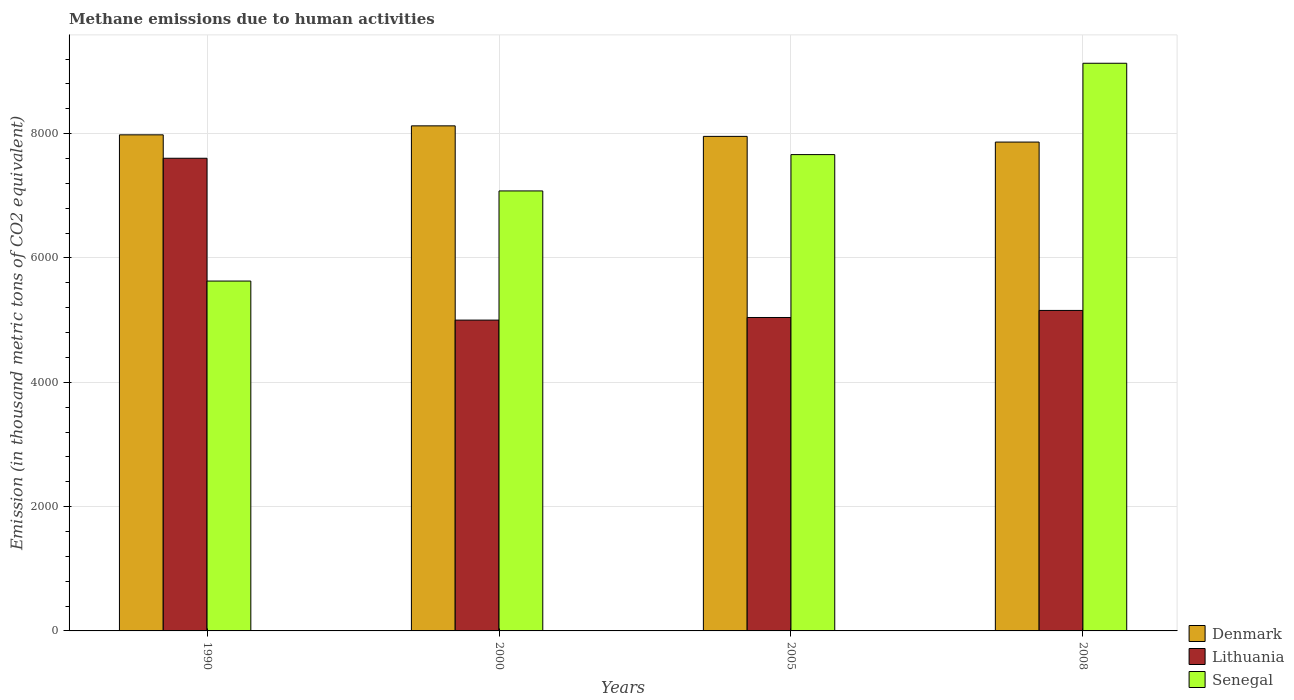How many different coloured bars are there?
Your answer should be compact. 3. Are the number of bars on each tick of the X-axis equal?
Your response must be concise. Yes. What is the amount of methane emitted in Senegal in 2000?
Offer a terse response. 7078.1. Across all years, what is the maximum amount of methane emitted in Lithuania?
Your response must be concise. 7603.6. Across all years, what is the minimum amount of methane emitted in Denmark?
Provide a succinct answer. 7864.1. What is the total amount of methane emitted in Lithuania in the graph?
Give a very brief answer. 2.28e+04. What is the difference between the amount of methane emitted in Lithuania in 1990 and that in 2000?
Your answer should be very brief. 2603.4. What is the difference between the amount of methane emitted in Lithuania in 2005 and the amount of methane emitted in Denmark in 1990?
Your answer should be compact. -2938.3. What is the average amount of methane emitted in Senegal per year?
Give a very brief answer. 7375.15. In the year 2005, what is the difference between the amount of methane emitted in Lithuania and amount of methane emitted in Senegal?
Keep it short and to the point. -2620.2. What is the ratio of the amount of methane emitted in Denmark in 2005 to that in 2008?
Give a very brief answer. 1.01. What is the difference between the highest and the second highest amount of methane emitted in Lithuania?
Provide a succinct answer. 2447.8. What is the difference between the highest and the lowest amount of methane emitted in Lithuania?
Provide a succinct answer. 2603.4. Is the sum of the amount of methane emitted in Lithuania in 2000 and 2005 greater than the maximum amount of methane emitted in Denmark across all years?
Provide a succinct answer. Yes. What does the 3rd bar from the left in 2008 represents?
Your answer should be compact. Senegal. What does the 2nd bar from the right in 2008 represents?
Your answer should be very brief. Lithuania. How many bars are there?
Provide a short and direct response. 12. Are all the bars in the graph horizontal?
Keep it short and to the point. No. What is the difference between two consecutive major ticks on the Y-axis?
Provide a succinct answer. 2000. Are the values on the major ticks of Y-axis written in scientific E-notation?
Keep it short and to the point. No. Does the graph contain any zero values?
Keep it short and to the point. No. Does the graph contain grids?
Keep it short and to the point. Yes. How many legend labels are there?
Offer a terse response. 3. How are the legend labels stacked?
Your answer should be very brief. Vertical. What is the title of the graph?
Give a very brief answer. Methane emissions due to human activities. Does "OECD members" appear as one of the legend labels in the graph?
Your answer should be compact. No. What is the label or title of the Y-axis?
Your response must be concise. Emission (in thousand metric tons of CO2 equivalent). What is the Emission (in thousand metric tons of CO2 equivalent) in Denmark in 1990?
Ensure brevity in your answer.  7980.5. What is the Emission (in thousand metric tons of CO2 equivalent) in Lithuania in 1990?
Provide a short and direct response. 7603.6. What is the Emission (in thousand metric tons of CO2 equivalent) of Senegal in 1990?
Provide a succinct answer. 5628.2. What is the Emission (in thousand metric tons of CO2 equivalent) of Denmark in 2000?
Your answer should be compact. 8124.9. What is the Emission (in thousand metric tons of CO2 equivalent) of Lithuania in 2000?
Your answer should be very brief. 5000.2. What is the Emission (in thousand metric tons of CO2 equivalent) in Senegal in 2000?
Your answer should be very brief. 7078.1. What is the Emission (in thousand metric tons of CO2 equivalent) of Denmark in 2005?
Give a very brief answer. 7955.5. What is the Emission (in thousand metric tons of CO2 equivalent) of Lithuania in 2005?
Your answer should be compact. 5042.2. What is the Emission (in thousand metric tons of CO2 equivalent) in Senegal in 2005?
Keep it short and to the point. 7662.4. What is the Emission (in thousand metric tons of CO2 equivalent) of Denmark in 2008?
Provide a succinct answer. 7864.1. What is the Emission (in thousand metric tons of CO2 equivalent) in Lithuania in 2008?
Provide a short and direct response. 5155.8. What is the Emission (in thousand metric tons of CO2 equivalent) of Senegal in 2008?
Your response must be concise. 9131.9. Across all years, what is the maximum Emission (in thousand metric tons of CO2 equivalent) of Denmark?
Make the answer very short. 8124.9. Across all years, what is the maximum Emission (in thousand metric tons of CO2 equivalent) of Lithuania?
Your answer should be compact. 7603.6. Across all years, what is the maximum Emission (in thousand metric tons of CO2 equivalent) in Senegal?
Provide a succinct answer. 9131.9. Across all years, what is the minimum Emission (in thousand metric tons of CO2 equivalent) of Denmark?
Keep it short and to the point. 7864.1. Across all years, what is the minimum Emission (in thousand metric tons of CO2 equivalent) in Lithuania?
Ensure brevity in your answer.  5000.2. Across all years, what is the minimum Emission (in thousand metric tons of CO2 equivalent) of Senegal?
Offer a terse response. 5628.2. What is the total Emission (in thousand metric tons of CO2 equivalent) of Denmark in the graph?
Offer a very short reply. 3.19e+04. What is the total Emission (in thousand metric tons of CO2 equivalent) of Lithuania in the graph?
Offer a very short reply. 2.28e+04. What is the total Emission (in thousand metric tons of CO2 equivalent) in Senegal in the graph?
Offer a terse response. 2.95e+04. What is the difference between the Emission (in thousand metric tons of CO2 equivalent) of Denmark in 1990 and that in 2000?
Give a very brief answer. -144.4. What is the difference between the Emission (in thousand metric tons of CO2 equivalent) in Lithuania in 1990 and that in 2000?
Your response must be concise. 2603.4. What is the difference between the Emission (in thousand metric tons of CO2 equivalent) of Senegal in 1990 and that in 2000?
Provide a short and direct response. -1449.9. What is the difference between the Emission (in thousand metric tons of CO2 equivalent) in Lithuania in 1990 and that in 2005?
Give a very brief answer. 2561.4. What is the difference between the Emission (in thousand metric tons of CO2 equivalent) in Senegal in 1990 and that in 2005?
Offer a very short reply. -2034.2. What is the difference between the Emission (in thousand metric tons of CO2 equivalent) in Denmark in 1990 and that in 2008?
Offer a terse response. 116.4. What is the difference between the Emission (in thousand metric tons of CO2 equivalent) in Lithuania in 1990 and that in 2008?
Provide a succinct answer. 2447.8. What is the difference between the Emission (in thousand metric tons of CO2 equivalent) of Senegal in 1990 and that in 2008?
Your answer should be very brief. -3503.7. What is the difference between the Emission (in thousand metric tons of CO2 equivalent) in Denmark in 2000 and that in 2005?
Provide a short and direct response. 169.4. What is the difference between the Emission (in thousand metric tons of CO2 equivalent) of Lithuania in 2000 and that in 2005?
Ensure brevity in your answer.  -42. What is the difference between the Emission (in thousand metric tons of CO2 equivalent) of Senegal in 2000 and that in 2005?
Your answer should be compact. -584.3. What is the difference between the Emission (in thousand metric tons of CO2 equivalent) in Denmark in 2000 and that in 2008?
Provide a short and direct response. 260.8. What is the difference between the Emission (in thousand metric tons of CO2 equivalent) in Lithuania in 2000 and that in 2008?
Make the answer very short. -155.6. What is the difference between the Emission (in thousand metric tons of CO2 equivalent) of Senegal in 2000 and that in 2008?
Your answer should be compact. -2053.8. What is the difference between the Emission (in thousand metric tons of CO2 equivalent) of Denmark in 2005 and that in 2008?
Make the answer very short. 91.4. What is the difference between the Emission (in thousand metric tons of CO2 equivalent) in Lithuania in 2005 and that in 2008?
Give a very brief answer. -113.6. What is the difference between the Emission (in thousand metric tons of CO2 equivalent) of Senegal in 2005 and that in 2008?
Give a very brief answer. -1469.5. What is the difference between the Emission (in thousand metric tons of CO2 equivalent) of Denmark in 1990 and the Emission (in thousand metric tons of CO2 equivalent) of Lithuania in 2000?
Your response must be concise. 2980.3. What is the difference between the Emission (in thousand metric tons of CO2 equivalent) in Denmark in 1990 and the Emission (in thousand metric tons of CO2 equivalent) in Senegal in 2000?
Your answer should be very brief. 902.4. What is the difference between the Emission (in thousand metric tons of CO2 equivalent) in Lithuania in 1990 and the Emission (in thousand metric tons of CO2 equivalent) in Senegal in 2000?
Ensure brevity in your answer.  525.5. What is the difference between the Emission (in thousand metric tons of CO2 equivalent) in Denmark in 1990 and the Emission (in thousand metric tons of CO2 equivalent) in Lithuania in 2005?
Give a very brief answer. 2938.3. What is the difference between the Emission (in thousand metric tons of CO2 equivalent) of Denmark in 1990 and the Emission (in thousand metric tons of CO2 equivalent) of Senegal in 2005?
Your answer should be very brief. 318.1. What is the difference between the Emission (in thousand metric tons of CO2 equivalent) of Lithuania in 1990 and the Emission (in thousand metric tons of CO2 equivalent) of Senegal in 2005?
Make the answer very short. -58.8. What is the difference between the Emission (in thousand metric tons of CO2 equivalent) in Denmark in 1990 and the Emission (in thousand metric tons of CO2 equivalent) in Lithuania in 2008?
Ensure brevity in your answer.  2824.7. What is the difference between the Emission (in thousand metric tons of CO2 equivalent) of Denmark in 1990 and the Emission (in thousand metric tons of CO2 equivalent) of Senegal in 2008?
Ensure brevity in your answer.  -1151.4. What is the difference between the Emission (in thousand metric tons of CO2 equivalent) of Lithuania in 1990 and the Emission (in thousand metric tons of CO2 equivalent) of Senegal in 2008?
Ensure brevity in your answer.  -1528.3. What is the difference between the Emission (in thousand metric tons of CO2 equivalent) of Denmark in 2000 and the Emission (in thousand metric tons of CO2 equivalent) of Lithuania in 2005?
Your answer should be compact. 3082.7. What is the difference between the Emission (in thousand metric tons of CO2 equivalent) of Denmark in 2000 and the Emission (in thousand metric tons of CO2 equivalent) of Senegal in 2005?
Your response must be concise. 462.5. What is the difference between the Emission (in thousand metric tons of CO2 equivalent) in Lithuania in 2000 and the Emission (in thousand metric tons of CO2 equivalent) in Senegal in 2005?
Provide a succinct answer. -2662.2. What is the difference between the Emission (in thousand metric tons of CO2 equivalent) of Denmark in 2000 and the Emission (in thousand metric tons of CO2 equivalent) of Lithuania in 2008?
Offer a terse response. 2969.1. What is the difference between the Emission (in thousand metric tons of CO2 equivalent) in Denmark in 2000 and the Emission (in thousand metric tons of CO2 equivalent) in Senegal in 2008?
Your answer should be very brief. -1007. What is the difference between the Emission (in thousand metric tons of CO2 equivalent) in Lithuania in 2000 and the Emission (in thousand metric tons of CO2 equivalent) in Senegal in 2008?
Give a very brief answer. -4131.7. What is the difference between the Emission (in thousand metric tons of CO2 equivalent) in Denmark in 2005 and the Emission (in thousand metric tons of CO2 equivalent) in Lithuania in 2008?
Your answer should be compact. 2799.7. What is the difference between the Emission (in thousand metric tons of CO2 equivalent) of Denmark in 2005 and the Emission (in thousand metric tons of CO2 equivalent) of Senegal in 2008?
Offer a very short reply. -1176.4. What is the difference between the Emission (in thousand metric tons of CO2 equivalent) in Lithuania in 2005 and the Emission (in thousand metric tons of CO2 equivalent) in Senegal in 2008?
Provide a succinct answer. -4089.7. What is the average Emission (in thousand metric tons of CO2 equivalent) of Denmark per year?
Your response must be concise. 7981.25. What is the average Emission (in thousand metric tons of CO2 equivalent) in Lithuania per year?
Keep it short and to the point. 5700.45. What is the average Emission (in thousand metric tons of CO2 equivalent) of Senegal per year?
Provide a short and direct response. 7375.15. In the year 1990, what is the difference between the Emission (in thousand metric tons of CO2 equivalent) of Denmark and Emission (in thousand metric tons of CO2 equivalent) of Lithuania?
Keep it short and to the point. 376.9. In the year 1990, what is the difference between the Emission (in thousand metric tons of CO2 equivalent) of Denmark and Emission (in thousand metric tons of CO2 equivalent) of Senegal?
Make the answer very short. 2352.3. In the year 1990, what is the difference between the Emission (in thousand metric tons of CO2 equivalent) in Lithuania and Emission (in thousand metric tons of CO2 equivalent) in Senegal?
Keep it short and to the point. 1975.4. In the year 2000, what is the difference between the Emission (in thousand metric tons of CO2 equivalent) in Denmark and Emission (in thousand metric tons of CO2 equivalent) in Lithuania?
Offer a terse response. 3124.7. In the year 2000, what is the difference between the Emission (in thousand metric tons of CO2 equivalent) of Denmark and Emission (in thousand metric tons of CO2 equivalent) of Senegal?
Provide a short and direct response. 1046.8. In the year 2000, what is the difference between the Emission (in thousand metric tons of CO2 equivalent) of Lithuania and Emission (in thousand metric tons of CO2 equivalent) of Senegal?
Keep it short and to the point. -2077.9. In the year 2005, what is the difference between the Emission (in thousand metric tons of CO2 equivalent) of Denmark and Emission (in thousand metric tons of CO2 equivalent) of Lithuania?
Provide a succinct answer. 2913.3. In the year 2005, what is the difference between the Emission (in thousand metric tons of CO2 equivalent) of Denmark and Emission (in thousand metric tons of CO2 equivalent) of Senegal?
Make the answer very short. 293.1. In the year 2005, what is the difference between the Emission (in thousand metric tons of CO2 equivalent) in Lithuania and Emission (in thousand metric tons of CO2 equivalent) in Senegal?
Your response must be concise. -2620.2. In the year 2008, what is the difference between the Emission (in thousand metric tons of CO2 equivalent) of Denmark and Emission (in thousand metric tons of CO2 equivalent) of Lithuania?
Provide a succinct answer. 2708.3. In the year 2008, what is the difference between the Emission (in thousand metric tons of CO2 equivalent) of Denmark and Emission (in thousand metric tons of CO2 equivalent) of Senegal?
Keep it short and to the point. -1267.8. In the year 2008, what is the difference between the Emission (in thousand metric tons of CO2 equivalent) of Lithuania and Emission (in thousand metric tons of CO2 equivalent) of Senegal?
Keep it short and to the point. -3976.1. What is the ratio of the Emission (in thousand metric tons of CO2 equivalent) in Denmark in 1990 to that in 2000?
Give a very brief answer. 0.98. What is the ratio of the Emission (in thousand metric tons of CO2 equivalent) of Lithuania in 1990 to that in 2000?
Keep it short and to the point. 1.52. What is the ratio of the Emission (in thousand metric tons of CO2 equivalent) of Senegal in 1990 to that in 2000?
Provide a short and direct response. 0.8. What is the ratio of the Emission (in thousand metric tons of CO2 equivalent) of Denmark in 1990 to that in 2005?
Your response must be concise. 1. What is the ratio of the Emission (in thousand metric tons of CO2 equivalent) in Lithuania in 1990 to that in 2005?
Make the answer very short. 1.51. What is the ratio of the Emission (in thousand metric tons of CO2 equivalent) of Senegal in 1990 to that in 2005?
Offer a very short reply. 0.73. What is the ratio of the Emission (in thousand metric tons of CO2 equivalent) in Denmark in 1990 to that in 2008?
Keep it short and to the point. 1.01. What is the ratio of the Emission (in thousand metric tons of CO2 equivalent) of Lithuania in 1990 to that in 2008?
Keep it short and to the point. 1.47. What is the ratio of the Emission (in thousand metric tons of CO2 equivalent) in Senegal in 1990 to that in 2008?
Ensure brevity in your answer.  0.62. What is the ratio of the Emission (in thousand metric tons of CO2 equivalent) of Denmark in 2000 to that in 2005?
Ensure brevity in your answer.  1.02. What is the ratio of the Emission (in thousand metric tons of CO2 equivalent) in Lithuania in 2000 to that in 2005?
Offer a terse response. 0.99. What is the ratio of the Emission (in thousand metric tons of CO2 equivalent) of Senegal in 2000 to that in 2005?
Offer a terse response. 0.92. What is the ratio of the Emission (in thousand metric tons of CO2 equivalent) in Denmark in 2000 to that in 2008?
Keep it short and to the point. 1.03. What is the ratio of the Emission (in thousand metric tons of CO2 equivalent) in Lithuania in 2000 to that in 2008?
Offer a terse response. 0.97. What is the ratio of the Emission (in thousand metric tons of CO2 equivalent) of Senegal in 2000 to that in 2008?
Provide a succinct answer. 0.78. What is the ratio of the Emission (in thousand metric tons of CO2 equivalent) of Denmark in 2005 to that in 2008?
Provide a succinct answer. 1.01. What is the ratio of the Emission (in thousand metric tons of CO2 equivalent) of Senegal in 2005 to that in 2008?
Offer a terse response. 0.84. What is the difference between the highest and the second highest Emission (in thousand metric tons of CO2 equivalent) in Denmark?
Give a very brief answer. 144.4. What is the difference between the highest and the second highest Emission (in thousand metric tons of CO2 equivalent) of Lithuania?
Your answer should be compact. 2447.8. What is the difference between the highest and the second highest Emission (in thousand metric tons of CO2 equivalent) of Senegal?
Your answer should be very brief. 1469.5. What is the difference between the highest and the lowest Emission (in thousand metric tons of CO2 equivalent) in Denmark?
Your response must be concise. 260.8. What is the difference between the highest and the lowest Emission (in thousand metric tons of CO2 equivalent) in Lithuania?
Ensure brevity in your answer.  2603.4. What is the difference between the highest and the lowest Emission (in thousand metric tons of CO2 equivalent) in Senegal?
Offer a very short reply. 3503.7. 